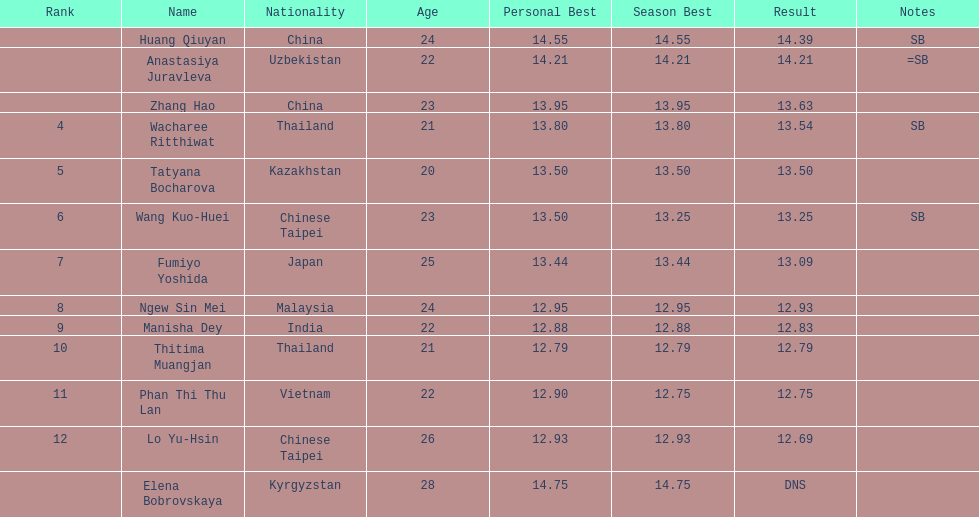How long was manisha dey's jump? 12.83. 